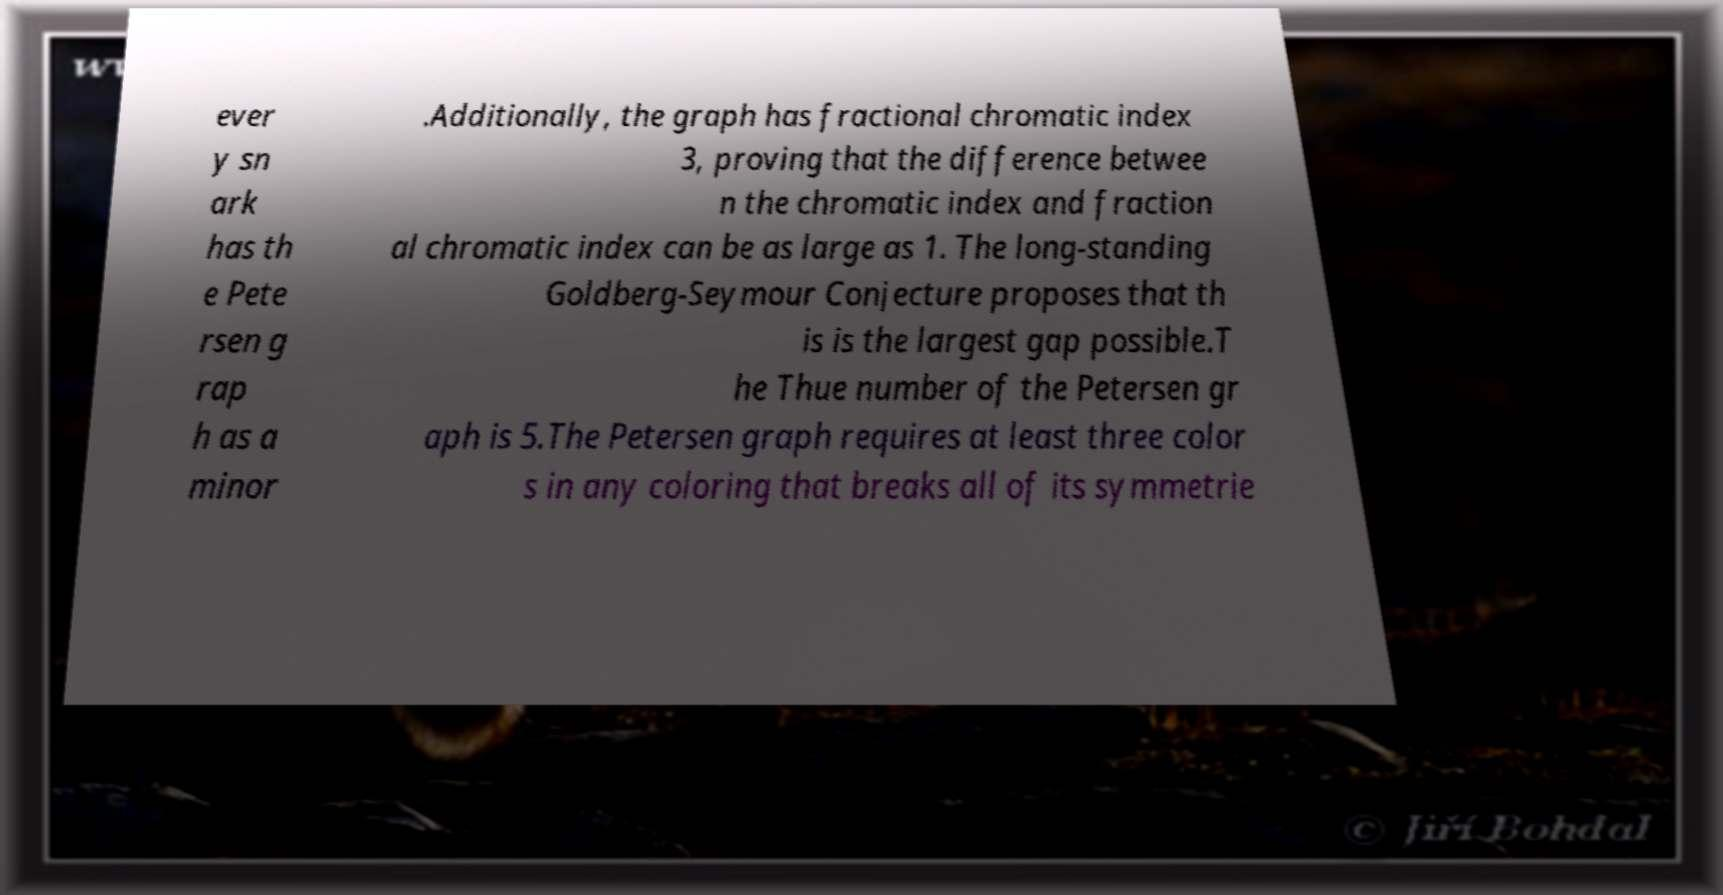For documentation purposes, I need the text within this image transcribed. Could you provide that? ever y sn ark has th e Pete rsen g rap h as a minor .Additionally, the graph has fractional chromatic index 3, proving that the difference betwee n the chromatic index and fraction al chromatic index can be as large as 1. The long-standing Goldberg-Seymour Conjecture proposes that th is is the largest gap possible.T he Thue number of the Petersen gr aph is 5.The Petersen graph requires at least three color s in any coloring that breaks all of its symmetrie 